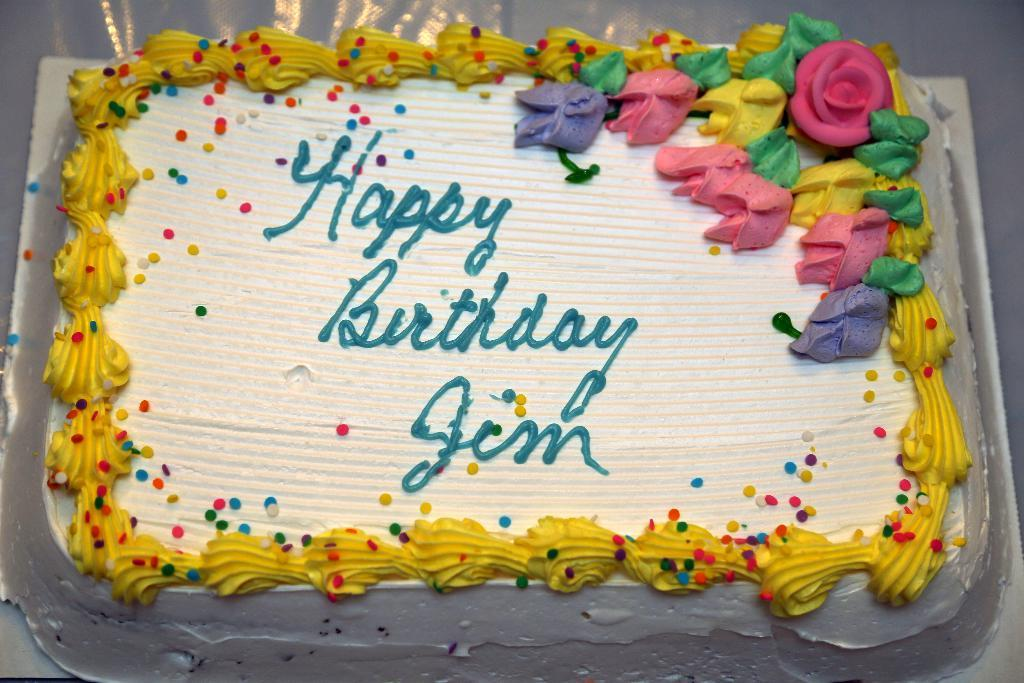What is the main subject of the image? There is a cake in the image. What is the cake placed on? The cake is placed on a white surface. Is there any writing or design on the cake? Yes, there is text on the cake. Can you see any visible veins on the cake in the image? There are no visible veins on the cake in the image, as veins are not a characteristic of cakes. 